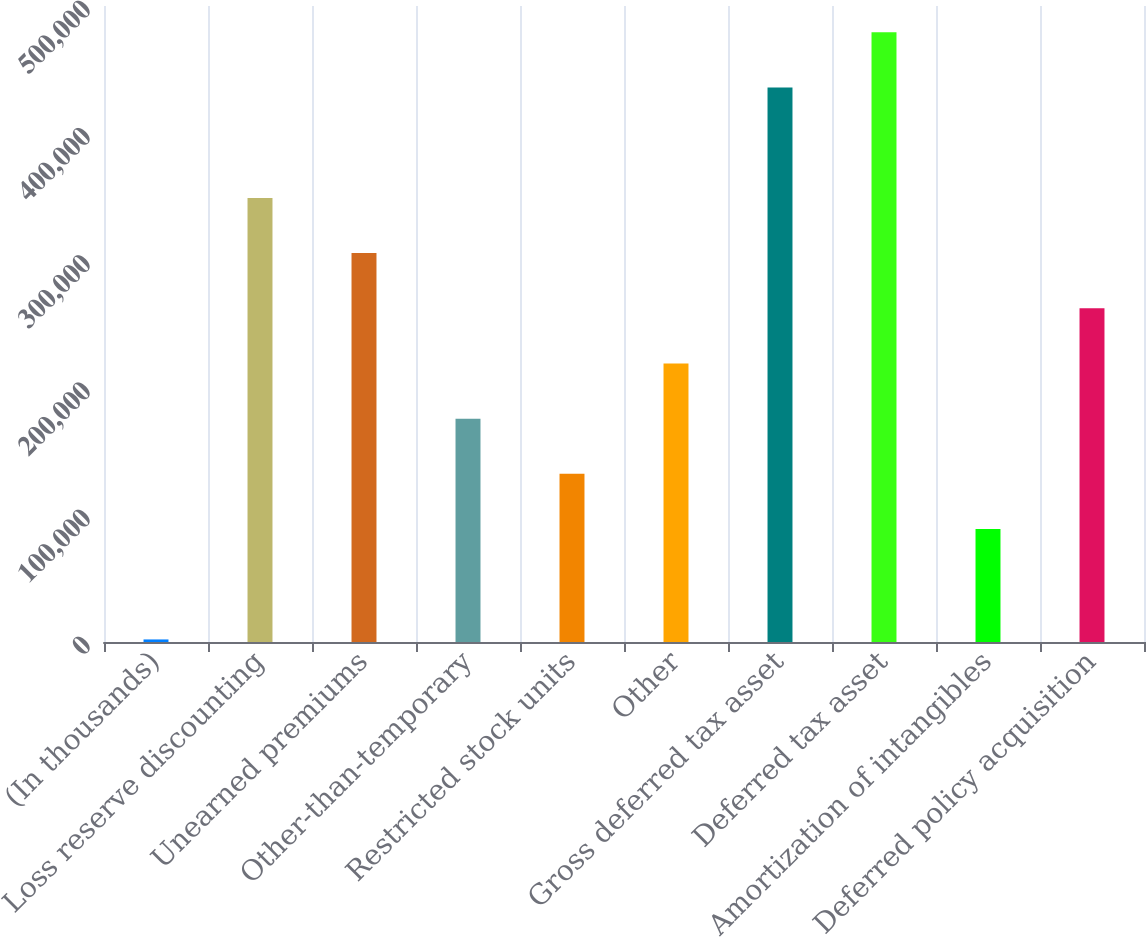Convert chart. <chart><loc_0><loc_0><loc_500><loc_500><bar_chart><fcel>(In thousands)<fcel>Loss reserve discounting<fcel>Unearned premiums<fcel>Other-than-temporary<fcel>Restricted stock units<fcel>Other<fcel>Gross deferred tax asset<fcel>Deferred tax asset<fcel>Amortization of intangibles<fcel>Deferred policy acquisition<nl><fcel>2011<fcel>349120<fcel>305731<fcel>175565<fcel>132177<fcel>218954<fcel>435897<fcel>479286<fcel>88788.2<fcel>262343<nl></chart> 